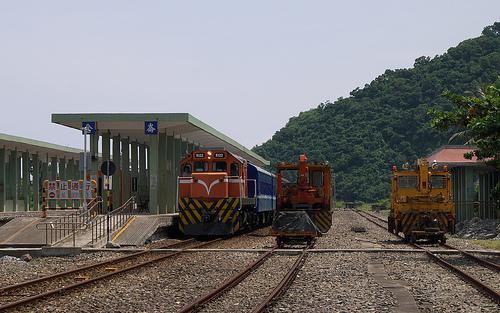Question: how many trains are there?
Choices:
A. 4.
B. 3.
C. 2.
D. 5.
Answer with the letter. Answer: B Question: where was this photo taken?
Choices:
A. Airport.
B. Bus station.
C. Parking lot.
D. Train Station.
Answer with the letter. Answer: D 